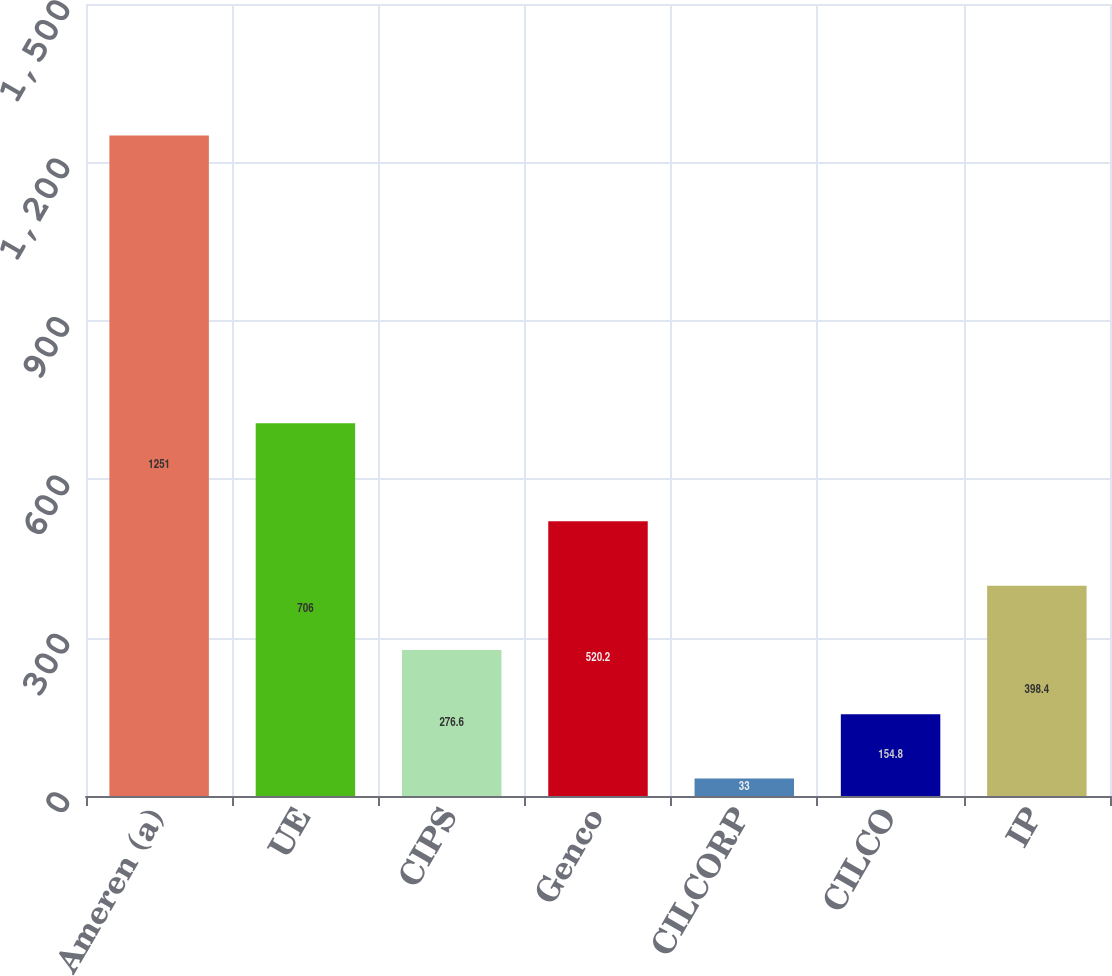Convert chart to OTSL. <chart><loc_0><loc_0><loc_500><loc_500><bar_chart><fcel>Ameren (a)<fcel>UE<fcel>CIPS<fcel>Genco<fcel>CILCORP<fcel>CILCO<fcel>IP<nl><fcel>1251<fcel>706<fcel>276.6<fcel>520.2<fcel>33<fcel>154.8<fcel>398.4<nl></chart> 